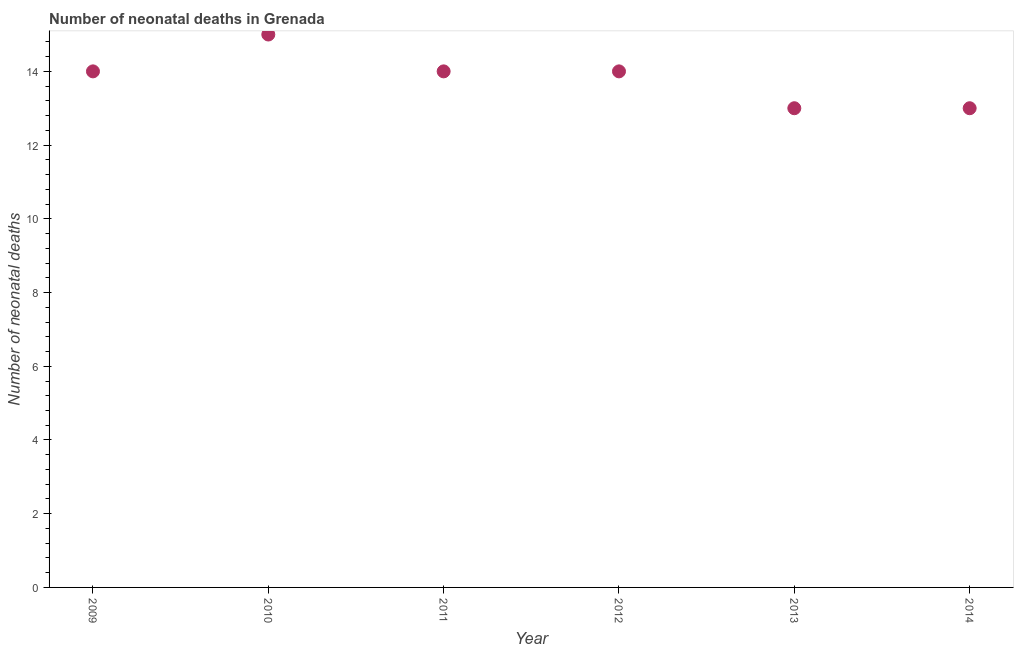What is the number of neonatal deaths in 2013?
Your answer should be compact. 13. Across all years, what is the maximum number of neonatal deaths?
Ensure brevity in your answer.  15. Across all years, what is the minimum number of neonatal deaths?
Your response must be concise. 13. In which year was the number of neonatal deaths maximum?
Your answer should be compact. 2010. In which year was the number of neonatal deaths minimum?
Keep it short and to the point. 2013. What is the sum of the number of neonatal deaths?
Give a very brief answer. 83. What is the difference between the number of neonatal deaths in 2010 and 2011?
Provide a succinct answer. 1. What is the average number of neonatal deaths per year?
Make the answer very short. 13.83. In how many years, is the number of neonatal deaths greater than 14.4 ?
Give a very brief answer. 1. What is the ratio of the number of neonatal deaths in 2009 to that in 2014?
Your answer should be compact. 1.08. Is the number of neonatal deaths in 2009 less than that in 2012?
Offer a terse response. No. What is the difference between the highest and the second highest number of neonatal deaths?
Your answer should be very brief. 1. What is the difference between the highest and the lowest number of neonatal deaths?
Your response must be concise. 2. In how many years, is the number of neonatal deaths greater than the average number of neonatal deaths taken over all years?
Your response must be concise. 4. Does the number of neonatal deaths monotonically increase over the years?
Your answer should be compact. No. What is the title of the graph?
Offer a terse response. Number of neonatal deaths in Grenada. What is the label or title of the X-axis?
Offer a very short reply. Year. What is the label or title of the Y-axis?
Provide a succinct answer. Number of neonatal deaths. What is the Number of neonatal deaths in 2010?
Provide a short and direct response. 15. What is the Number of neonatal deaths in 2011?
Give a very brief answer. 14. What is the Number of neonatal deaths in 2013?
Provide a short and direct response. 13. What is the difference between the Number of neonatal deaths in 2009 and 2011?
Your response must be concise. 0. What is the difference between the Number of neonatal deaths in 2009 and 2013?
Provide a short and direct response. 1. What is the difference between the Number of neonatal deaths in 2010 and 2014?
Your answer should be very brief. 2. What is the difference between the Number of neonatal deaths in 2011 and 2012?
Provide a succinct answer. 0. What is the difference between the Number of neonatal deaths in 2011 and 2014?
Offer a terse response. 1. What is the difference between the Number of neonatal deaths in 2012 and 2013?
Provide a succinct answer. 1. What is the ratio of the Number of neonatal deaths in 2009 to that in 2010?
Your answer should be compact. 0.93. What is the ratio of the Number of neonatal deaths in 2009 to that in 2011?
Ensure brevity in your answer.  1. What is the ratio of the Number of neonatal deaths in 2009 to that in 2012?
Keep it short and to the point. 1. What is the ratio of the Number of neonatal deaths in 2009 to that in 2013?
Offer a very short reply. 1.08. What is the ratio of the Number of neonatal deaths in 2009 to that in 2014?
Offer a terse response. 1.08. What is the ratio of the Number of neonatal deaths in 2010 to that in 2011?
Provide a short and direct response. 1.07. What is the ratio of the Number of neonatal deaths in 2010 to that in 2012?
Ensure brevity in your answer.  1.07. What is the ratio of the Number of neonatal deaths in 2010 to that in 2013?
Your answer should be very brief. 1.15. What is the ratio of the Number of neonatal deaths in 2010 to that in 2014?
Provide a succinct answer. 1.15. What is the ratio of the Number of neonatal deaths in 2011 to that in 2012?
Give a very brief answer. 1. What is the ratio of the Number of neonatal deaths in 2011 to that in 2013?
Ensure brevity in your answer.  1.08. What is the ratio of the Number of neonatal deaths in 2011 to that in 2014?
Give a very brief answer. 1.08. What is the ratio of the Number of neonatal deaths in 2012 to that in 2013?
Your answer should be very brief. 1.08. What is the ratio of the Number of neonatal deaths in 2012 to that in 2014?
Your answer should be compact. 1.08. What is the ratio of the Number of neonatal deaths in 2013 to that in 2014?
Give a very brief answer. 1. 